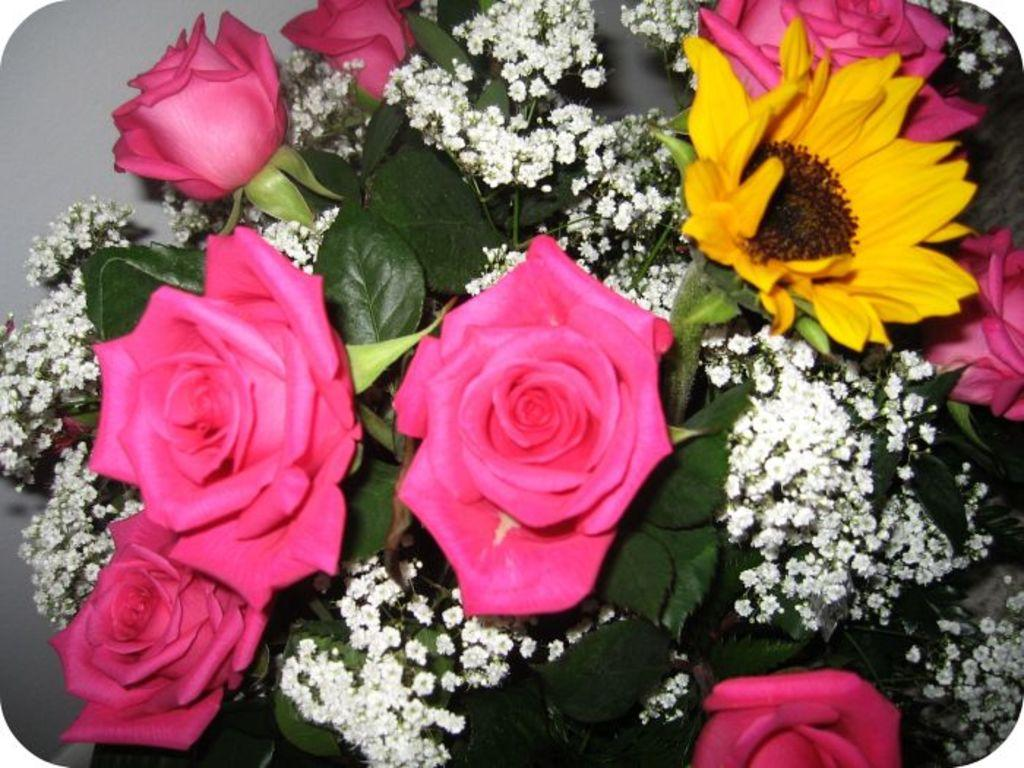What type of flora can be seen in the image? There are flowers in the image. Can you describe the colors of the flowers? The flowers are of white, pink, and yellow colors. What else is present in the image besides the flowers? There are leaves in the image. Where is the ship located in the image? There is no ship present in the image; it features flowers and leaves. What type of hydrant is visible in the image? There is no hydrant present in the image; it features flowers and leaves. 